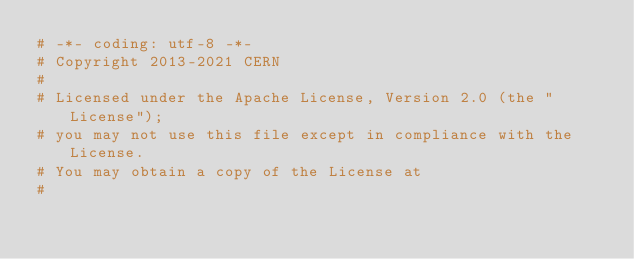Convert code to text. <code><loc_0><loc_0><loc_500><loc_500><_Python_># -*- coding: utf-8 -*-
# Copyright 2013-2021 CERN
#
# Licensed under the Apache License, Version 2.0 (the "License");
# you may not use this file except in compliance with the License.
# You may obtain a copy of the License at
#</code> 